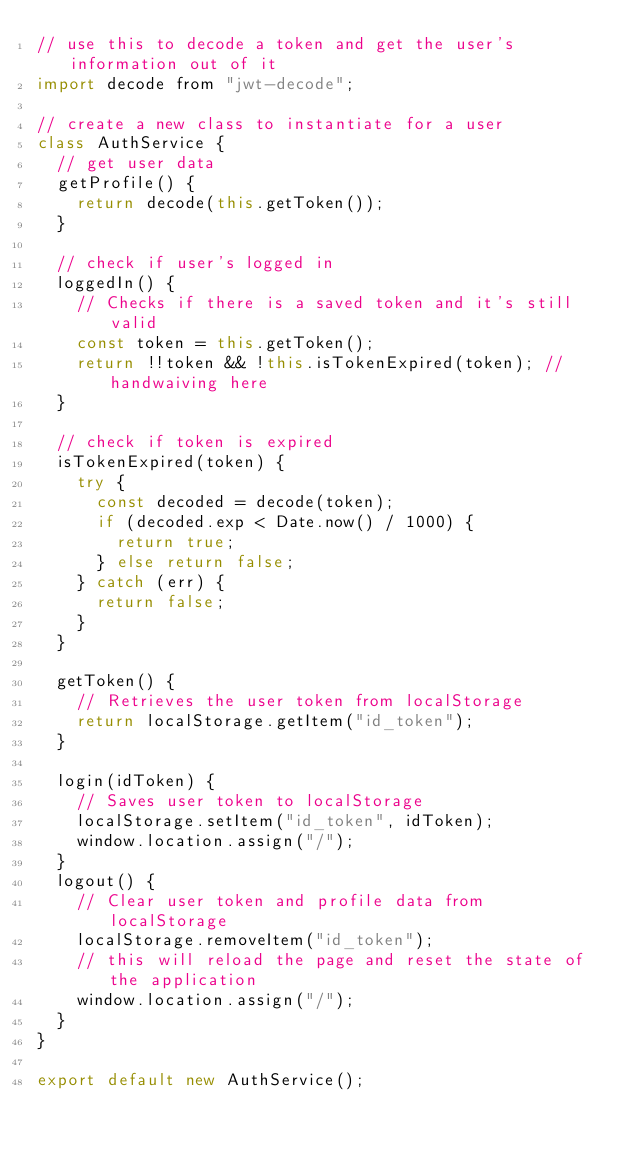Convert code to text. <code><loc_0><loc_0><loc_500><loc_500><_JavaScript_>// use this to decode a token and get the user's information out of it
import decode from "jwt-decode";

// create a new class to instantiate for a user
class AuthService {
  // get user data
  getProfile() {
    return decode(this.getToken());
  }

  // check if user's logged in
  loggedIn() {
    // Checks if there is a saved token and it's still valid
    const token = this.getToken();
    return !!token && !this.isTokenExpired(token); // handwaiving here
  }

  // check if token is expired
  isTokenExpired(token) {
    try {
      const decoded = decode(token);
      if (decoded.exp < Date.now() / 1000) {
        return true;
      } else return false;
    } catch (err) {
      return false;
    }
  }

  getToken() {
    // Retrieves the user token from localStorage
    return localStorage.getItem("id_token");
  }

  login(idToken) {
    // Saves user token to localStorage
    localStorage.setItem("id_token", idToken);
    window.location.assign("/");
  }
  logout() {
    // Clear user token and profile data from localStorage
    localStorage.removeItem("id_token");
    // this will reload the page and reset the state of the application
    window.location.assign("/");
  }
}

export default new AuthService();
</code> 